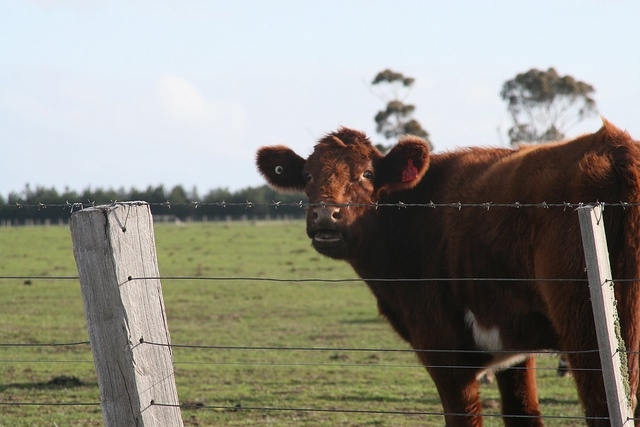Describe the objects in this image and their specific colors. I can see a cow in lavender, black, maroon, and gray tones in this image. 